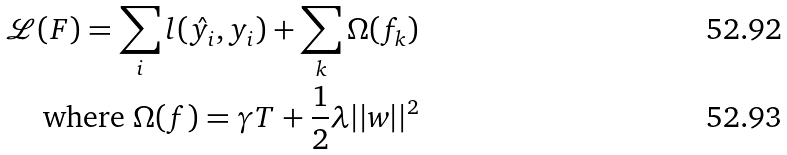Convert formula to latex. <formula><loc_0><loc_0><loc_500><loc_500>\mathcal { L } ( F ) = \sum _ { i } { l ( \hat { y _ { i } } , y _ { i } ) } + \sum _ { k } \Omega ( f _ { k } ) \\ \text {where} \ \Omega ( f ) = \gamma T + \frac { 1 } { 2 } \lambda | | w | | ^ { 2 }</formula> 